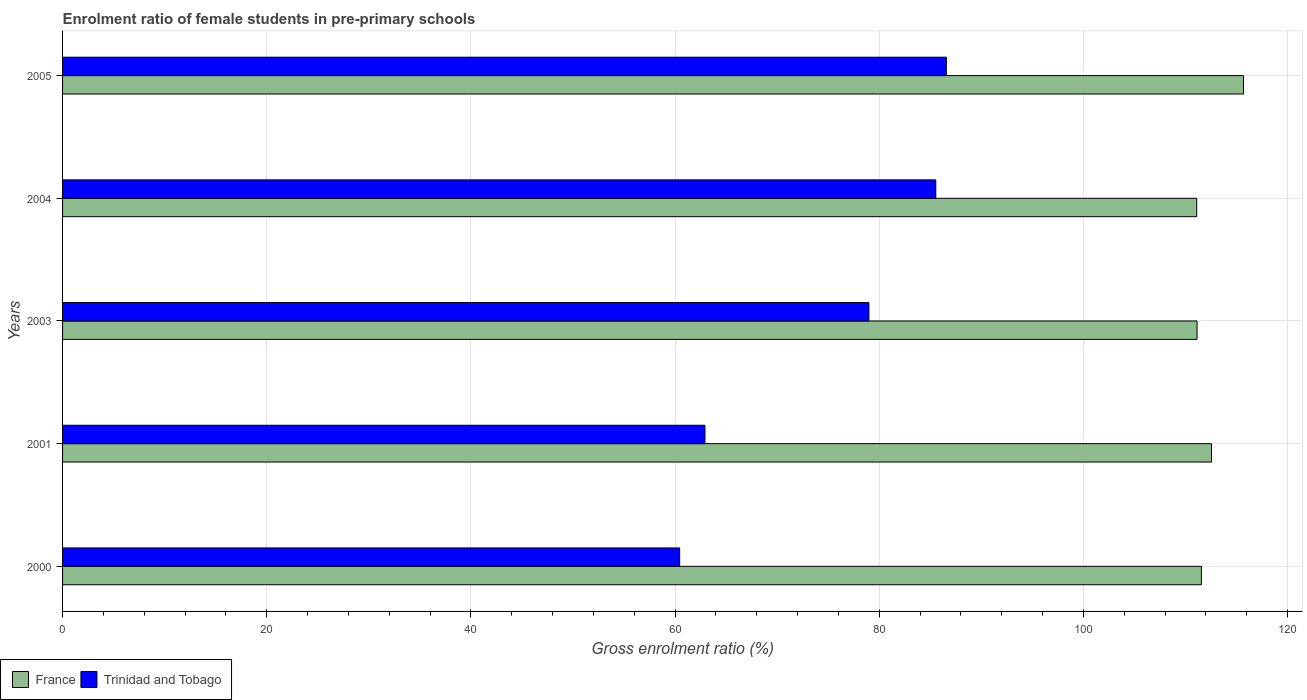How many groups of bars are there?
Your answer should be compact. 5. Are the number of bars on each tick of the Y-axis equal?
Keep it short and to the point. Yes. How many bars are there on the 3rd tick from the bottom?
Your response must be concise. 2. What is the enrolment ratio of female students in pre-primary schools in France in 2001?
Your answer should be compact. 112.55. Across all years, what is the maximum enrolment ratio of female students in pre-primary schools in France?
Your answer should be compact. 115.68. Across all years, what is the minimum enrolment ratio of female students in pre-primary schools in Trinidad and Tobago?
Offer a terse response. 60.45. In which year was the enrolment ratio of female students in pre-primary schools in Trinidad and Tobago minimum?
Your answer should be very brief. 2000. What is the total enrolment ratio of female students in pre-primary schools in Trinidad and Tobago in the graph?
Provide a succinct answer. 374.48. What is the difference between the enrolment ratio of female students in pre-primary schools in France in 2003 and that in 2004?
Provide a short and direct response. 0.03. What is the difference between the enrolment ratio of female students in pre-primary schools in Trinidad and Tobago in 2005 and the enrolment ratio of female students in pre-primary schools in France in 2003?
Keep it short and to the point. -24.56. What is the average enrolment ratio of female students in pre-primary schools in Trinidad and Tobago per year?
Your answer should be compact. 74.9. In the year 2004, what is the difference between the enrolment ratio of female students in pre-primary schools in Trinidad and Tobago and enrolment ratio of female students in pre-primary schools in France?
Make the answer very short. -25.56. In how many years, is the enrolment ratio of female students in pre-primary schools in France greater than 56 %?
Make the answer very short. 5. What is the ratio of the enrolment ratio of female students in pre-primary schools in Trinidad and Tobago in 2004 to that in 2005?
Offer a very short reply. 0.99. What is the difference between the highest and the second highest enrolment ratio of female students in pre-primary schools in Trinidad and Tobago?
Your answer should be very brief. 1.03. What is the difference between the highest and the lowest enrolment ratio of female students in pre-primary schools in Trinidad and Tobago?
Provide a succinct answer. 26.12. What does the 1st bar from the bottom in 2004 represents?
Offer a terse response. France. Does the graph contain any zero values?
Offer a very short reply. No. How are the legend labels stacked?
Your response must be concise. Horizontal. What is the title of the graph?
Your response must be concise. Enrolment ratio of female students in pre-primary schools. What is the label or title of the X-axis?
Ensure brevity in your answer.  Gross enrolment ratio (%). What is the label or title of the Y-axis?
Provide a succinct answer. Years. What is the Gross enrolment ratio (%) of France in 2000?
Offer a terse response. 111.56. What is the Gross enrolment ratio (%) in Trinidad and Tobago in 2000?
Your response must be concise. 60.45. What is the Gross enrolment ratio (%) in France in 2001?
Keep it short and to the point. 112.55. What is the Gross enrolment ratio (%) in Trinidad and Tobago in 2001?
Your answer should be very brief. 62.93. What is the Gross enrolment ratio (%) in France in 2003?
Your answer should be very brief. 111.13. What is the Gross enrolment ratio (%) in Trinidad and Tobago in 2003?
Offer a very short reply. 78.99. What is the Gross enrolment ratio (%) of France in 2004?
Your answer should be very brief. 111.1. What is the Gross enrolment ratio (%) of Trinidad and Tobago in 2004?
Give a very brief answer. 85.54. What is the Gross enrolment ratio (%) in France in 2005?
Provide a short and direct response. 115.68. What is the Gross enrolment ratio (%) of Trinidad and Tobago in 2005?
Provide a succinct answer. 86.57. Across all years, what is the maximum Gross enrolment ratio (%) in France?
Your answer should be compact. 115.68. Across all years, what is the maximum Gross enrolment ratio (%) in Trinidad and Tobago?
Offer a very short reply. 86.57. Across all years, what is the minimum Gross enrolment ratio (%) of France?
Offer a terse response. 111.1. Across all years, what is the minimum Gross enrolment ratio (%) of Trinidad and Tobago?
Keep it short and to the point. 60.45. What is the total Gross enrolment ratio (%) of France in the graph?
Give a very brief answer. 562.01. What is the total Gross enrolment ratio (%) of Trinidad and Tobago in the graph?
Your answer should be compact. 374.48. What is the difference between the Gross enrolment ratio (%) in France in 2000 and that in 2001?
Give a very brief answer. -0.99. What is the difference between the Gross enrolment ratio (%) of Trinidad and Tobago in 2000 and that in 2001?
Offer a terse response. -2.48. What is the difference between the Gross enrolment ratio (%) in France in 2000 and that in 2003?
Make the answer very short. 0.43. What is the difference between the Gross enrolment ratio (%) of Trinidad and Tobago in 2000 and that in 2003?
Make the answer very short. -18.54. What is the difference between the Gross enrolment ratio (%) in France in 2000 and that in 2004?
Ensure brevity in your answer.  0.46. What is the difference between the Gross enrolment ratio (%) in Trinidad and Tobago in 2000 and that in 2004?
Your response must be concise. -25.09. What is the difference between the Gross enrolment ratio (%) in France in 2000 and that in 2005?
Offer a terse response. -4.12. What is the difference between the Gross enrolment ratio (%) of Trinidad and Tobago in 2000 and that in 2005?
Keep it short and to the point. -26.12. What is the difference between the Gross enrolment ratio (%) of France in 2001 and that in 2003?
Make the answer very short. 1.42. What is the difference between the Gross enrolment ratio (%) of Trinidad and Tobago in 2001 and that in 2003?
Provide a short and direct response. -16.06. What is the difference between the Gross enrolment ratio (%) in France in 2001 and that in 2004?
Make the answer very short. 1.45. What is the difference between the Gross enrolment ratio (%) of Trinidad and Tobago in 2001 and that in 2004?
Your answer should be very brief. -22.61. What is the difference between the Gross enrolment ratio (%) of France in 2001 and that in 2005?
Keep it short and to the point. -3.13. What is the difference between the Gross enrolment ratio (%) in Trinidad and Tobago in 2001 and that in 2005?
Make the answer very short. -23.65. What is the difference between the Gross enrolment ratio (%) of France in 2003 and that in 2004?
Provide a succinct answer. 0.03. What is the difference between the Gross enrolment ratio (%) in Trinidad and Tobago in 2003 and that in 2004?
Ensure brevity in your answer.  -6.55. What is the difference between the Gross enrolment ratio (%) in France in 2003 and that in 2005?
Provide a short and direct response. -4.55. What is the difference between the Gross enrolment ratio (%) in Trinidad and Tobago in 2003 and that in 2005?
Your answer should be compact. -7.59. What is the difference between the Gross enrolment ratio (%) in France in 2004 and that in 2005?
Your response must be concise. -4.58. What is the difference between the Gross enrolment ratio (%) in Trinidad and Tobago in 2004 and that in 2005?
Offer a very short reply. -1.03. What is the difference between the Gross enrolment ratio (%) of France in 2000 and the Gross enrolment ratio (%) of Trinidad and Tobago in 2001?
Ensure brevity in your answer.  48.63. What is the difference between the Gross enrolment ratio (%) of France in 2000 and the Gross enrolment ratio (%) of Trinidad and Tobago in 2003?
Your answer should be very brief. 32.57. What is the difference between the Gross enrolment ratio (%) in France in 2000 and the Gross enrolment ratio (%) in Trinidad and Tobago in 2004?
Make the answer very short. 26.02. What is the difference between the Gross enrolment ratio (%) of France in 2000 and the Gross enrolment ratio (%) of Trinidad and Tobago in 2005?
Provide a short and direct response. 24.98. What is the difference between the Gross enrolment ratio (%) of France in 2001 and the Gross enrolment ratio (%) of Trinidad and Tobago in 2003?
Keep it short and to the point. 33.56. What is the difference between the Gross enrolment ratio (%) of France in 2001 and the Gross enrolment ratio (%) of Trinidad and Tobago in 2004?
Provide a succinct answer. 27.01. What is the difference between the Gross enrolment ratio (%) in France in 2001 and the Gross enrolment ratio (%) in Trinidad and Tobago in 2005?
Offer a very short reply. 25.97. What is the difference between the Gross enrolment ratio (%) in France in 2003 and the Gross enrolment ratio (%) in Trinidad and Tobago in 2004?
Give a very brief answer. 25.59. What is the difference between the Gross enrolment ratio (%) in France in 2003 and the Gross enrolment ratio (%) in Trinidad and Tobago in 2005?
Give a very brief answer. 24.56. What is the difference between the Gross enrolment ratio (%) in France in 2004 and the Gross enrolment ratio (%) in Trinidad and Tobago in 2005?
Offer a very short reply. 24.53. What is the average Gross enrolment ratio (%) in France per year?
Give a very brief answer. 112.4. What is the average Gross enrolment ratio (%) of Trinidad and Tobago per year?
Keep it short and to the point. 74.9. In the year 2000, what is the difference between the Gross enrolment ratio (%) in France and Gross enrolment ratio (%) in Trinidad and Tobago?
Offer a terse response. 51.11. In the year 2001, what is the difference between the Gross enrolment ratio (%) in France and Gross enrolment ratio (%) in Trinidad and Tobago?
Provide a short and direct response. 49.62. In the year 2003, what is the difference between the Gross enrolment ratio (%) in France and Gross enrolment ratio (%) in Trinidad and Tobago?
Your response must be concise. 32.14. In the year 2004, what is the difference between the Gross enrolment ratio (%) in France and Gross enrolment ratio (%) in Trinidad and Tobago?
Provide a succinct answer. 25.56. In the year 2005, what is the difference between the Gross enrolment ratio (%) of France and Gross enrolment ratio (%) of Trinidad and Tobago?
Give a very brief answer. 29.1. What is the ratio of the Gross enrolment ratio (%) in Trinidad and Tobago in 2000 to that in 2001?
Ensure brevity in your answer.  0.96. What is the ratio of the Gross enrolment ratio (%) in Trinidad and Tobago in 2000 to that in 2003?
Give a very brief answer. 0.77. What is the ratio of the Gross enrolment ratio (%) in Trinidad and Tobago in 2000 to that in 2004?
Keep it short and to the point. 0.71. What is the ratio of the Gross enrolment ratio (%) of France in 2000 to that in 2005?
Offer a very short reply. 0.96. What is the ratio of the Gross enrolment ratio (%) in Trinidad and Tobago in 2000 to that in 2005?
Offer a very short reply. 0.7. What is the ratio of the Gross enrolment ratio (%) in France in 2001 to that in 2003?
Provide a succinct answer. 1.01. What is the ratio of the Gross enrolment ratio (%) of Trinidad and Tobago in 2001 to that in 2003?
Your response must be concise. 0.8. What is the ratio of the Gross enrolment ratio (%) in Trinidad and Tobago in 2001 to that in 2004?
Your response must be concise. 0.74. What is the ratio of the Gross enrolment ratio (%) in France in 2001 to that in 2005?
Offer a very short reply. 0.97. What is the ratio of the Gross enrolment ratio (%) of Trinidad and Tobago in 2001 to that in 2005?
Offer a very short reply. 0.73. What is the ratio of the Gross enrolment ratio (%) of Trinidad and Tobago in 2003 to that in 2004?
Your response must be concise. 0.92. What is the ratio of the Gross enrolment ratio (%) in France in 2003 to that in 2005?
Make the answer very short. 0.96. What is the ratio of the Gross enrolment ratio (%) of Trinidad and Tobago in 2003 to that in 2005?
Give a very brief answer. 0.91. What is the ratio of the Gross enrolment ratio (%) in France in 2004 to that in 2005?
Provide a short and direct response. 0.96. What is the difference between the highest and the second highest Gross enrolment ratio (%) in France?
Give a very brief answer. 3.13. What is the difference between the highest and the second highest Gross enrolment ratio (%) of Trinidad and Tobago?
Your response must be concise. 1.03. What is the difference between the highest and the lowest Gross enrolment ratio (%) in France?
Your answer should be very brief. 4.58. What is the difference between the highest and the lowest Gross enrolment ratio (%) in Trinidad and Tobago?
Give a very brief answer. 26.12. 